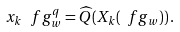Convert formula to latex. <formula><loc_0><loc_0><loc_500><loc_500>x _ { k } \, \ f g _ { w } ^ { q } = \widehat { Q } ( X _ { k } ( \ f g _ { w } ) ) \, .</formula> 